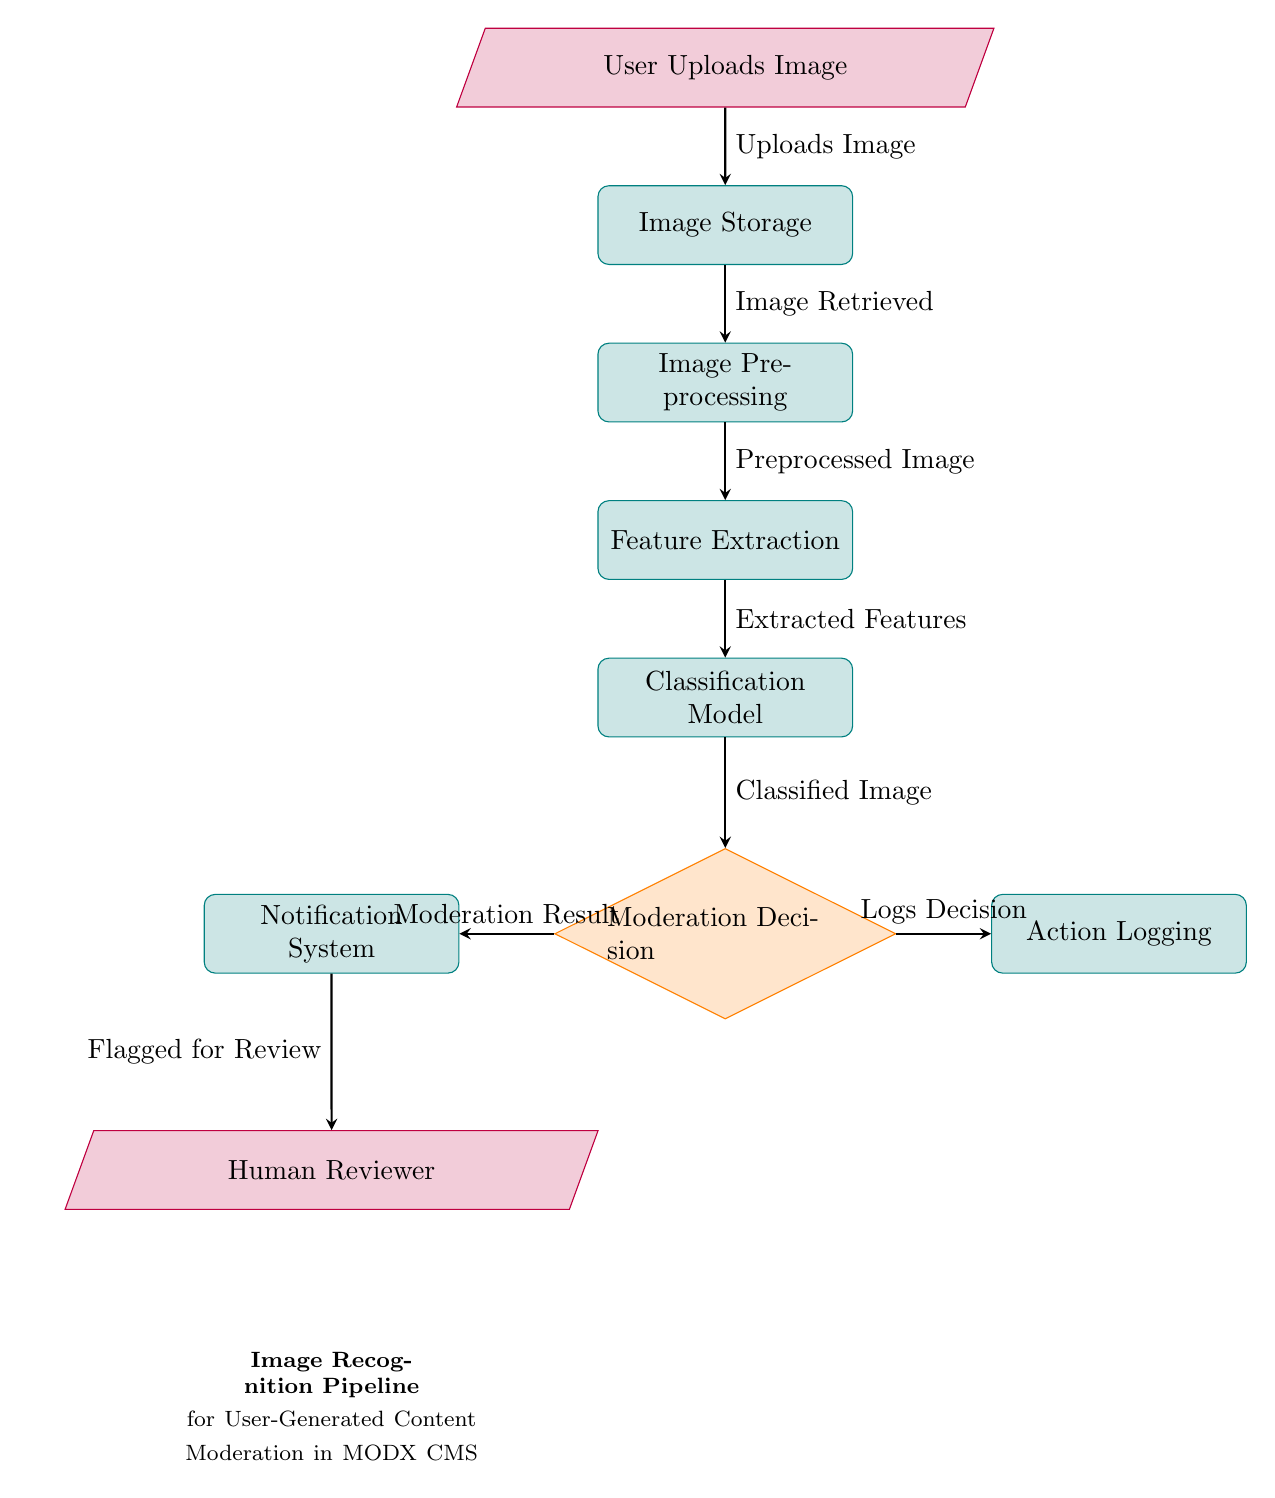What is the first step in the diagram? The first step in the diagram is represented by the node labeled "User Uploads Image." This is indicated as the starting point of the process, with an arrow leading to the next node.
Answer: User Uploads Image How many processes are shown in the diagram? By counting the nodes categorized as processes (rounded rectangles), we identify five: Image Storage, Image Preprocessing, Feature Extraction, Classification Model, and Notification System, making a total of five process nodes.
Answer: Five What decision is made after the Classification Model? The Classification Model leads to a decision node labeled "Moderation Decision," indicating that a moderation decision is to be made based on the classified image.
Answer: Moderation Decision What is the output of the Moderation Decision? The Moderation Decision outputs two results: it either activates the Notification System or logs the decision, indicating the respective actions taken based on the moderation result.
Answer: Moderation Result What happens to flagged images according to the diagram? Flagged images based on the moderation decision are sent to a node labeled "Human Reviewer," indicating that human review is part of the moderation process for flagged content.
Answer: Flagged for Review Which node indicates storage of images? The node labeled "Image Storage" represents the function of storing images that are uploaded by users before any processing takes place.
Answer: Image Storage What type of model is used in this pipeline? The node labeled "Classification Model" indicates that a classification model is employed in the pipeline to analyze images after feature extraction.
Answer: Classification Model Where does the flow of processed images lead after feature extraction? After feature extraction, the flow of processed images leads to the "Classification Model," where the extracted features are classified into categories.
Answer: Classification Model 